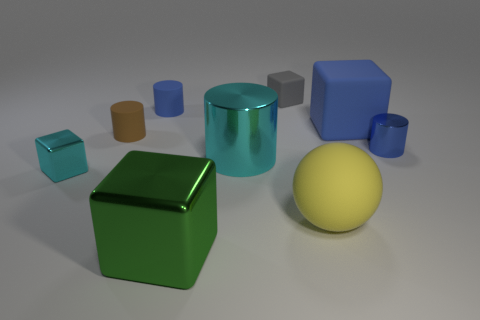What materials are shown in the objects within the image? The objects seem to display different materials, including glossy, matte, and reflective surfaces, categorized by how they interact with the light. 